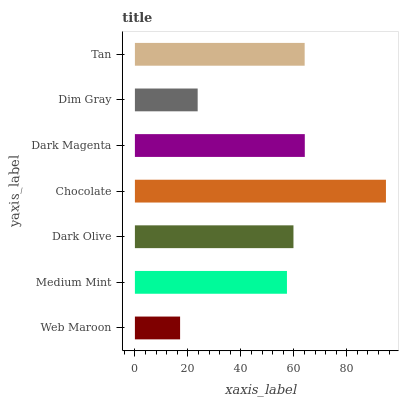Is Web Maroon the minimum?
Answer yes or no. Yes. Is Chocolate the maximum?
Answer yes or no. Yes. Is Medium Mint the minimum?
Answer yes or no. No. Is Medium Mint the maximum?
Answer yes or no. No. Is Medium Mint greater than Web Maroon?
Answer yes or no. Yes. Is Web Maroon less than Medium Mint?
Answer yes or no. Yes. Is Web Maroon greater than Medium Mint?
Answer yes or no. No. Is Medium Mint less than Web Maroon?
Answer yes or no. No. Is Dark Olive the high median?
Answer yes or no. Yes. Is Dark Olive the low median?
Answer yes or no. Yes. Is Tan the high median?
Answer yes or no. No. Is Web Maroon the low median?
Answer yes or no. No. 